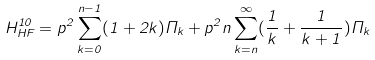Convert formula to latex. <formula><loc_0><loc_0><loc_500><loc_500>H _ { H F } ^ { 1 0 } = p ^ { 2 } \sum _ { k = 0 } ^ { n - 1 } ( 1 + 2 k ) \Pi _ { k } + p ^ { 2 } n \sum _ { k = n } ^ { \infty } ( \frac { 1 } { k } + \frac { 1 } { k + 1 } ) \Pi _ { k }</formula> 